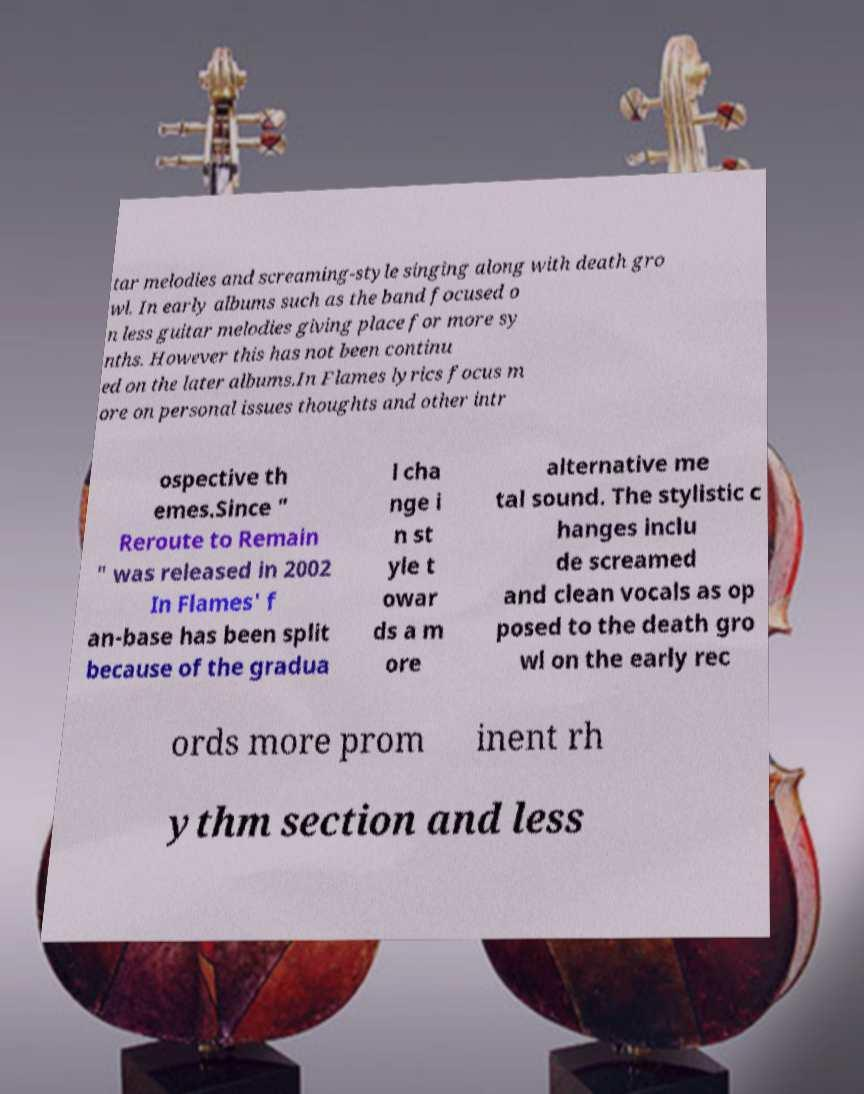Could you extract and type out the text from this image? tar melodies and screaming-style singing along with death gro wl. In early albums such as the band focused o n less guitar melodies giving place for more sy nths. However this has not been continu ed on the later albums.In Flames lyrics focus m ore on personal issues thoughts and other intr ospective th emes.Since " Reroute to Remain " was released in 2002 In Flames' f an-base has been split because of the gradua l cha nge i n st yle t owar ds a m ore alternative me tal sound. The stylistic c hanges inclu de screamed and clean vocals as op posed to the death gro wl on the early rec ords more prom inent rh ythm section and less 